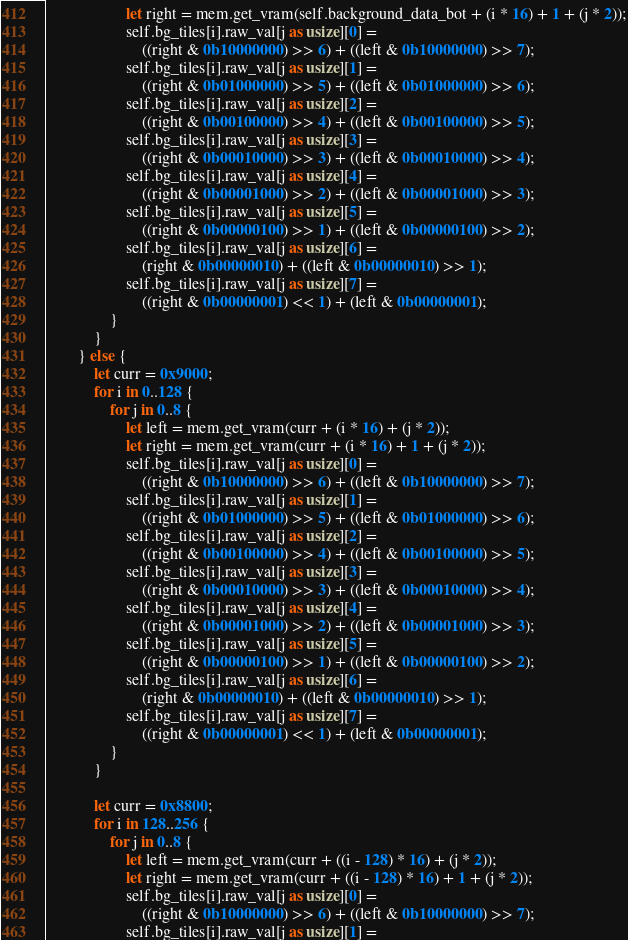<code> <loc_0><loc_0><loc_500><loc_500><_Rust_>                    let right = mem.get_vram(self.background_data_bot + (i * 16) + 1 + (j * 2));
                    self.bg_tiles[i].raw_val[j as usize][0] =
                        ((right & 0b10000000) >> 6) + ((left & 0b10000000) >> 7);
                    self.bg_tiles[i].raw_val[j as usize][1] =
                        ((right & 0b01000000) >> 5) + ((left & 0b01000000) >> 6);
                    self.bg_tiles[i].raw_val[j as usize][2] =
                        ((right & 0b00100000) >> 4) + ((left & 0b00100000) >> 5);
                    self.bg_tiles[i].raw_val[j as usize][3] =
                        ((right & 0b00010000) >> 3) + ((left & 0b00010000) >> 4);
                    self.bg_tiles[i].raw_val[j as usize][4] =
                        ((right & 0b00001000) >> 2) + ((left & 0b00001000) >> 3);
                    self.bg_tiles[i].raw_val[j as usize][5] =
                        ((right & 0b00000100) >> 1) + ((left & 0b00000100) >> 2);
                    self.bg_tiles[i].raw_val[j as usize][6] =
                        (right & 0b00000010) + ((left & 0b00000010) >> 1);
                    self.bg_tiles[i].raw_val[j as usize][7] =
                        ((right & 0b00000001) << 1) + (left & 0b00000001);
                }
            }
        } else {
            let curr = 0x9000;
            for i in 0..128 {
                for j in 0..8 {
                    let left = mem.get_vram(curr + (i * 16) + (j * 2));
                    let right = mem.get_vram(curr + (i * 16) + 1 + (j * 2));
                    self.bg_tiles[i].raw_val[j as usize][0] =
                        ((right & 0b10000000) >> 6) + ((left & 0b10000000) >> 7);
                    self.bg_tiles[i].raw_val[j as usize][1] =
                        ((right & 0b01000000) >> 5) + ((left & 0b01000000) >> 6);
                    self.bg_tiles[i].raw_val[j as usize][2] =
                        ((right & 0b00100000) >> 4) + ((left & 0b00100000) >> 5);
                    self.bg_tiles[i].raw_val[j as usize][3] =
                        ((right & 0b00010000) >> 3) + ((left & 0b00010000) >> 4);
                    self.bg_tiles[i].raw_val[j as usize][4] =
                        ((right & 0b00001000) >> 2) + ((left & 0b00001000) >> 3);
                    self.bg_tiles[i].raw_val[j as usize][5] =
                        ((right & 0b00000100) >> 1) + ((left & 0b00000100) >> 2);
                    self.bg_tiles[i].raw_val[j as usize][6] =
                        (right & 0b00000010) + ((left & 0b00000010) >> 1);
                    self.bg_tiles[i].raw_val[j as usize][7] =
                        ((right & 0b00000001) << 1) + (left & 0b00000001);
                }
            }

            let curr = 0x8800;
            for i in 128..256 {
                for j in 0..8 {
                    let left = mem.get_vram(curr + ((i - 128) * 16) + (j * 2));
                    let right = mem.get_vram(curr + ((i - 128) * 16) + 1 + (j * 2));
                    self.bg_tiles[i].raw_val[j as usize][0] =
                        ((right & 0b10000000) >> 6) + ((left & 0b10000000) >> 7);
                    self.bg_tiles[i].raw_val[j as usize][1] =</code> 